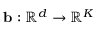<formula> <loc_0><loc_0><loc_500><loc_500>b \colon \mathbb { R } ^ { d } \to \mathbb { R } ^ { K }</formula> 